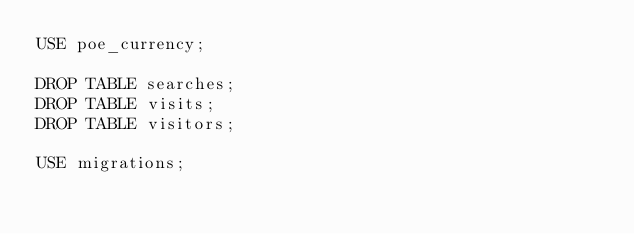Convert code to text. <code><loc_0><loc_0><loc_500><loc_500><_SQL_>USE poe_currency;

DROP TABLE searches;
DROP TABLE visits;
DROP TABLE visitors;

USE migrations;</code> 